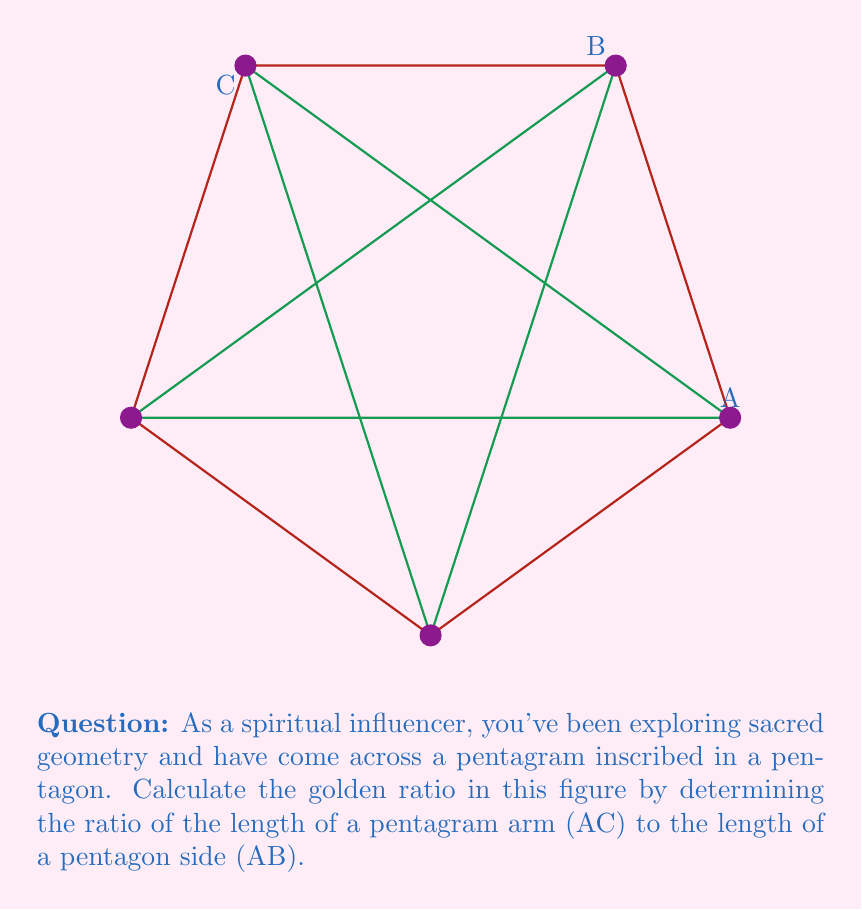Provide a solution to this math problem. Let's approach this step-by-step:

1) In a regular pentagon, the ratio of a diagonal to a side is equal to the golden ratio, φ. This is a fundamental property of pentagons and pentagrams.

2) In the pentagram, AC is a diagonal of the pentagon, and AB is a side.

3) The golden ratio is defined as:

   $$φ = \frac{1 + \sqrt{5}}{2}$$

4) To calculate this:

   $$φ = \frac{1 + \sqrt{5}}{2}$$

   $$= \frac{1 + 2.236068}{2}$$

   $$= \frac{3.236068}{2}$$

   $$= 1.618034$$

5) Therefore, the ratio of AC to AB is approximately 1.618034 to 1.

This ratio, known as the golden ratio or divine proportion, is found throughout nature and has been used in art and architecture for its aesthetic appeal. It's often associated with spiritual and mystical properties in sacred geometry.
Answer: $φ = \frac{1 + \sqrt{5}}{2} \approx 1.618034$ 